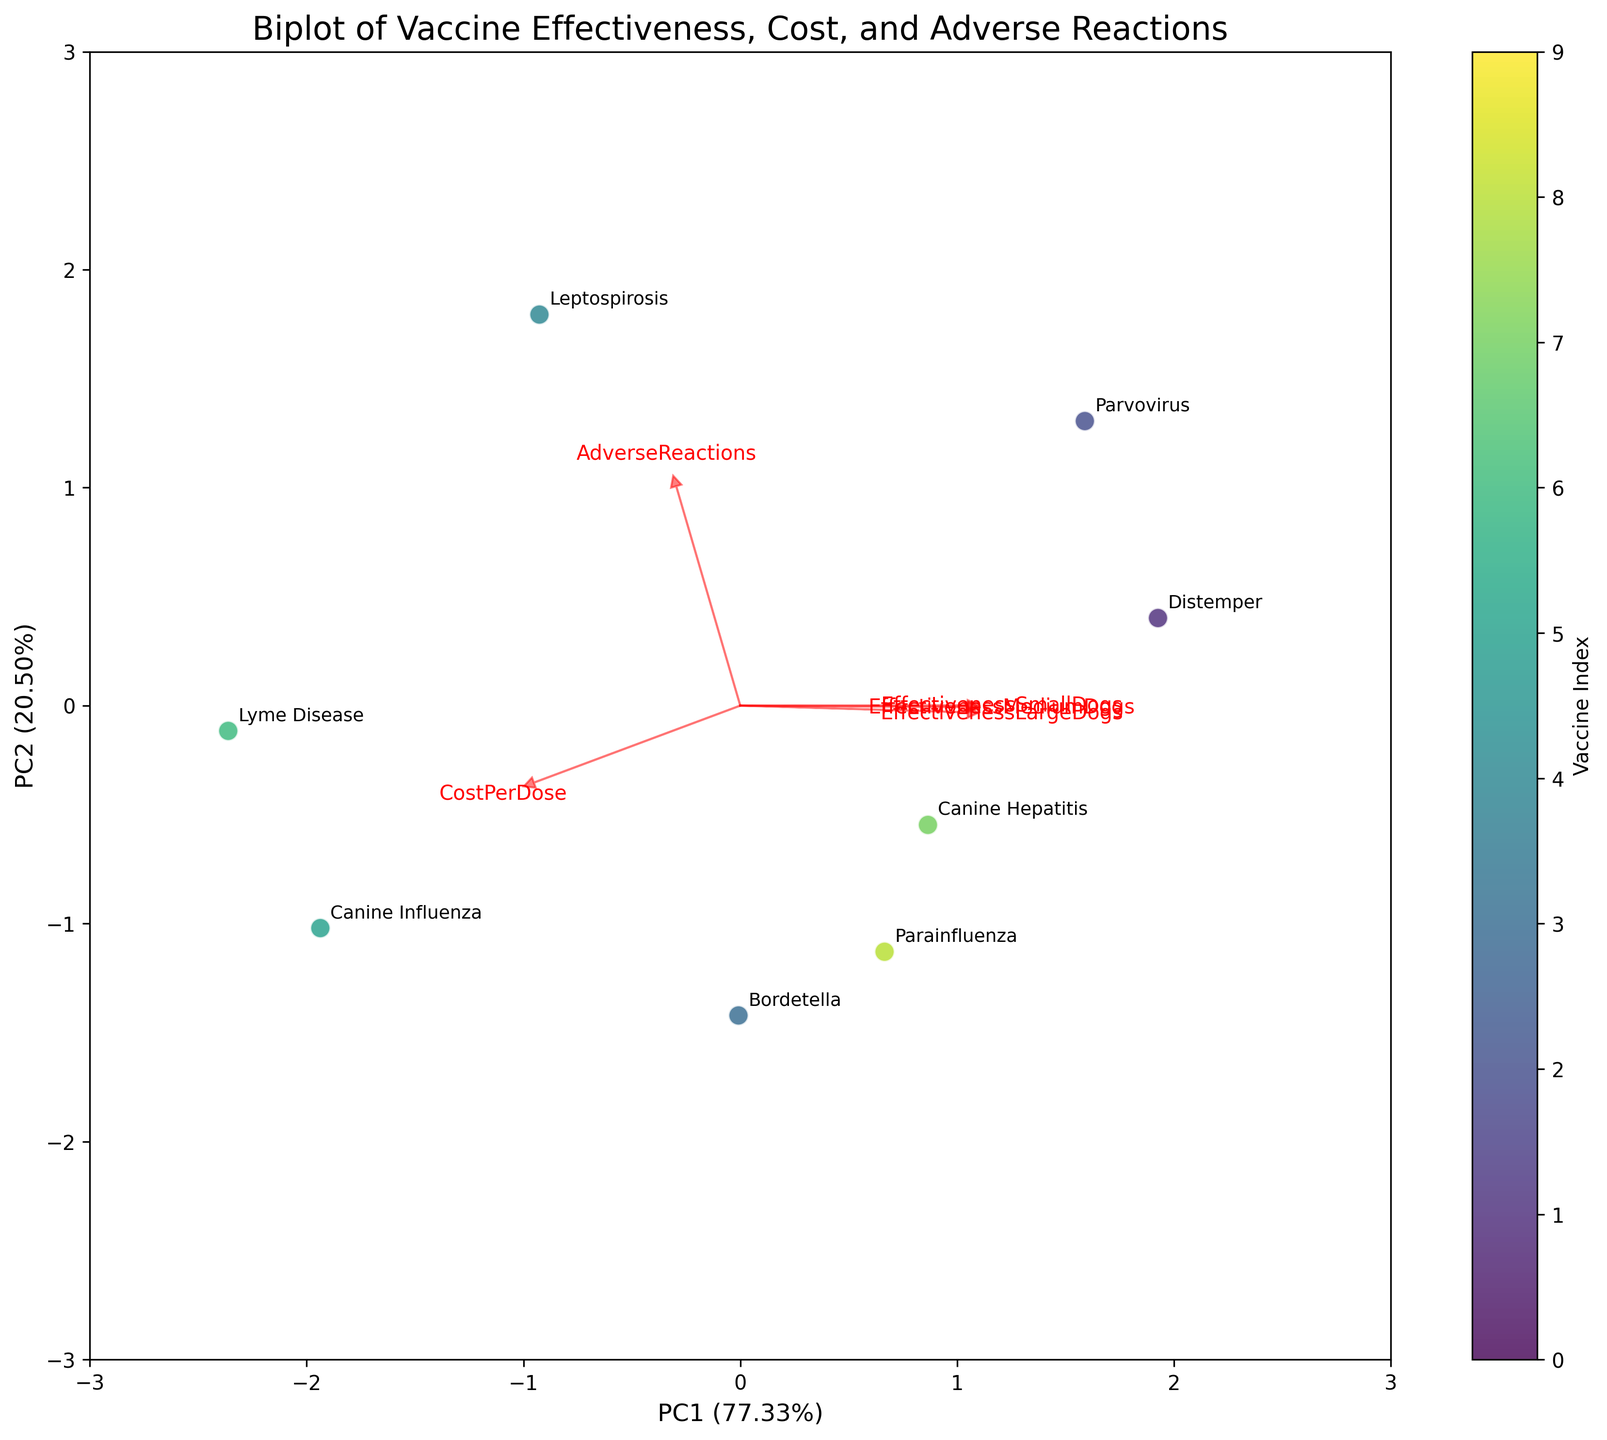How many principal components are shown on the biplot? The x-axis and y-axis are labeled as PC1 and PC2, respectively, indicating that two principal components are shown.
Answer: Two What are the labels of the arrows on the biplot representing? Each arrow is labeled with the name of a feature such as 'EffectivenessSmallDogs', 'EffectivenessMediumDogs', 'EffectivenessLargeDogs', 'CostPerDose', and 'AdverseReactions', indicating the direction and magnitude of their linear association with the principal components.
Answer: Feature names Which vaccine has the highest effectiveness in small dogs according to the biplot? By examining the annotations on the biplot, 'Rabies' is placed furthest along the effectiveness vector for small dogs, indicating it has the highest effectiveness.
Answer: Rabies Compare the position of the Canine Influenza vaccine to the Lyme Disease vaccine. Which one has higher adverse reactions? ‘Adverse Reactions’ arrow points in the direction where the vaccine with higher adverse reactions will be located. 'Canine Influenza' is farther along this vector compared to 'Lyme Disease', implying higher adverse reactions.
Answer: Canine Influenza What does the direction of the 'CostPerDose' arrow indicate? The 'CostPerDose' arrow points in a specific direction which signifies that as you move along that direction from the origin, the cost per dose of the vaccines increases.
Answer: Increases Which two features appear to be most strongly correlated according to the biplot? The arrows for 'EffectivenessMediumDogs' and 'EffectivenessLargeDogs' are closely aligned in the same direction, indicating a strong positive correlation between these two features.
Answer: Effectiveness in Medium and Large Dogs Which vaccine has the lowest cost per dose according to the plot? By observing the positions relative to the 'CostPerDose' vector, 'Rabies' appears closest to the origin along this direction, indicating the lowest cost per dose.
Answer: Rabies Are adverse reactions and effectiveness highly correlated for small dogs? The arrows for 'AdverseReactions' and 'EffectivenessSmallDogs' are not pointing in the same direction, indicating a low or possibly negative correlation between these two features.
Answer: No Which vaccines are closely positioned together on the biplot, and what might that indicate? 'Distemper' and 'Parvovirus' are closely positioned together, suggesting they have similar profiles in terms of effectiveness, cost, and adverse reactions based on how PCA has transformed the dataset.
Answer: Distemper and Parvovirus What percentage of total variance is explained by the first principal component (PC1)? By looking at the label of the x-axis, PC1 explains 42.3% of the total variance.
Answer: 42.3% 